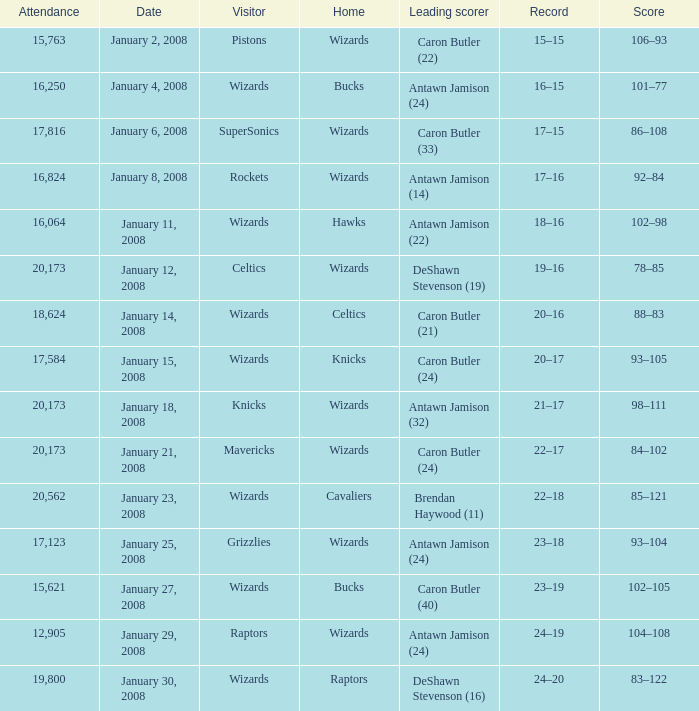What is the record when the leading scorer is Antawn Jamison (14)? 17–16. 